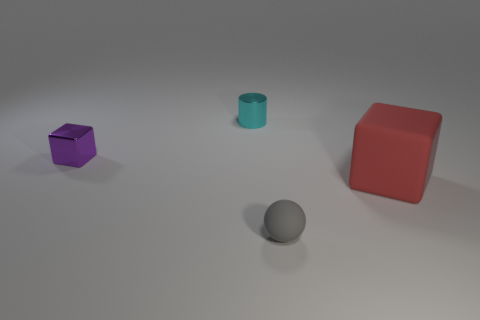Add 3 shiny things. How many objects exist? 7 Subtract all cylinders. How many objects are left? 3 Subtract 1 purple cubes. How many objects are left? 3 Subtract all tiny purple blocks. Subtract all big red rubber things. How many objects are left? 2 Add 1 small purple metal things. How many small purple metal things are left? 2 Add 1 tiny cylinders. How many tiny cylinders exist? 2 